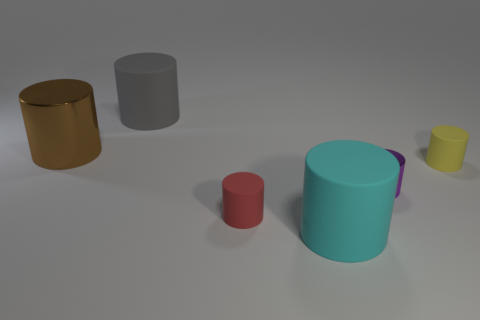What number of tiny purple things have the same shape as the small yellow matte object?
Make the answer very short. 1. Is the yellow matte thing the same shape as the small purple metal thing?
Give a very brief answer. Yes. The purple object has what size?
Your response must be concise. Small. What number of shiny things have the same size as the cyan rubber object?
Your answer should be compact. 1. Do the metal object right of the gray thing and the yellow thing that is in front of the gray matte thing have the same size?
Ensure brevity in your answer.  Yes. There is a large brown cylinder left of the small matte cylinder that is to the left of the tiny purple cylinder; what is it made of?
Give a very brief answer. Metal. There is a red matte cylinder; does it have the same size as the cylinder that is left of the big gray matte thing?
Your response must be concise. No. There is a large cylinder in front of the tiny thing that is on the left side of the big cyan matte cylinder; how many matte cylinders are right of it?
Your answer should be compact. 1. What number of big metal objects are right of the tiny purple metal object?
Give a very brief answer. 0. There is a large rubber cylinder in front of the tiny matte thing that is behind the purple thing; what color is it?
Offer a very short reply. Cyan. 